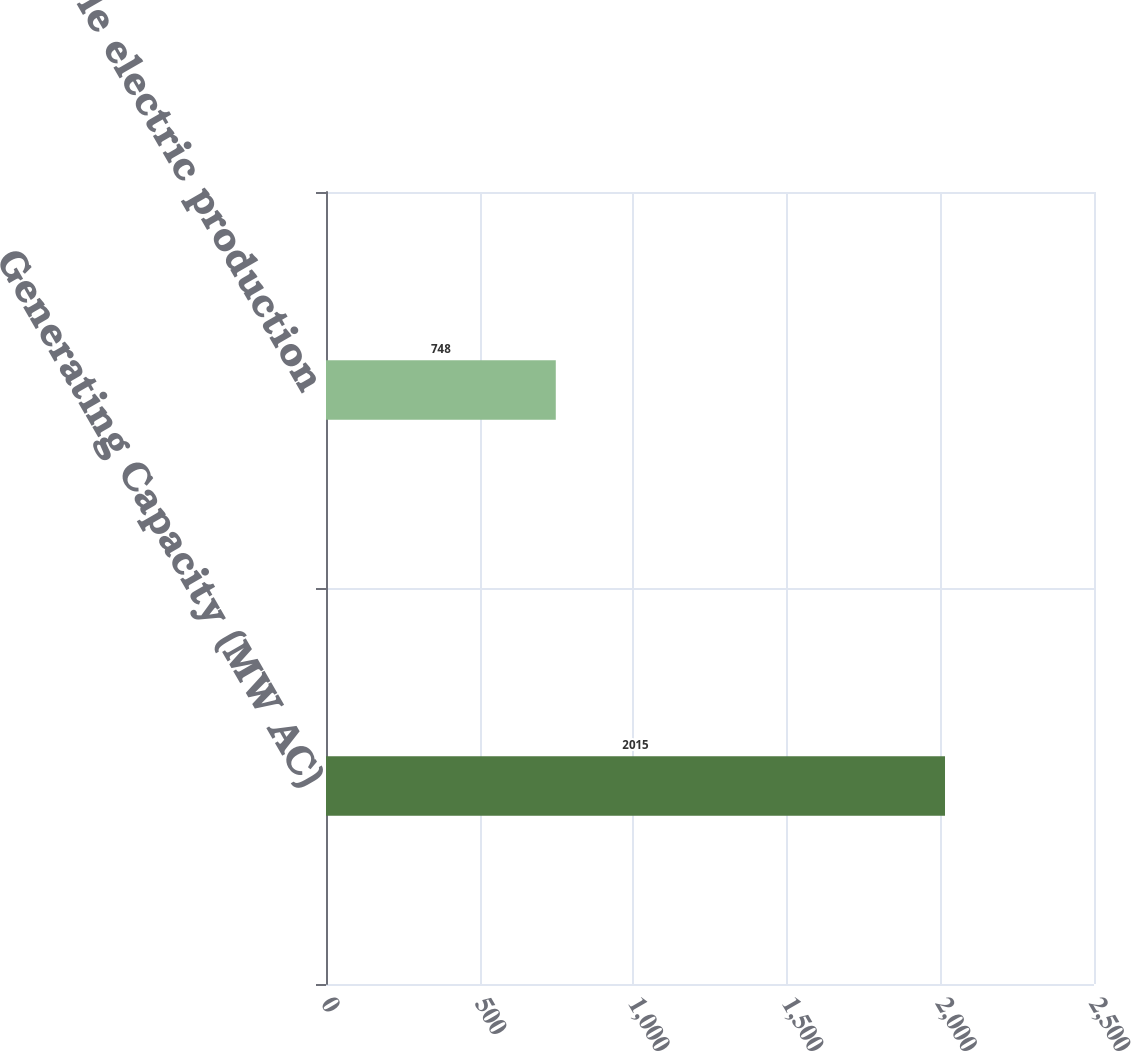Convert chart. <chart><loc_0><loc_0><loc_500><loc_500><bar_chart><fcel>Generating Capacity (MW AC)<fcel>Renewable electric production<nl><fcel>2015<fcel>748<nl></chart> 